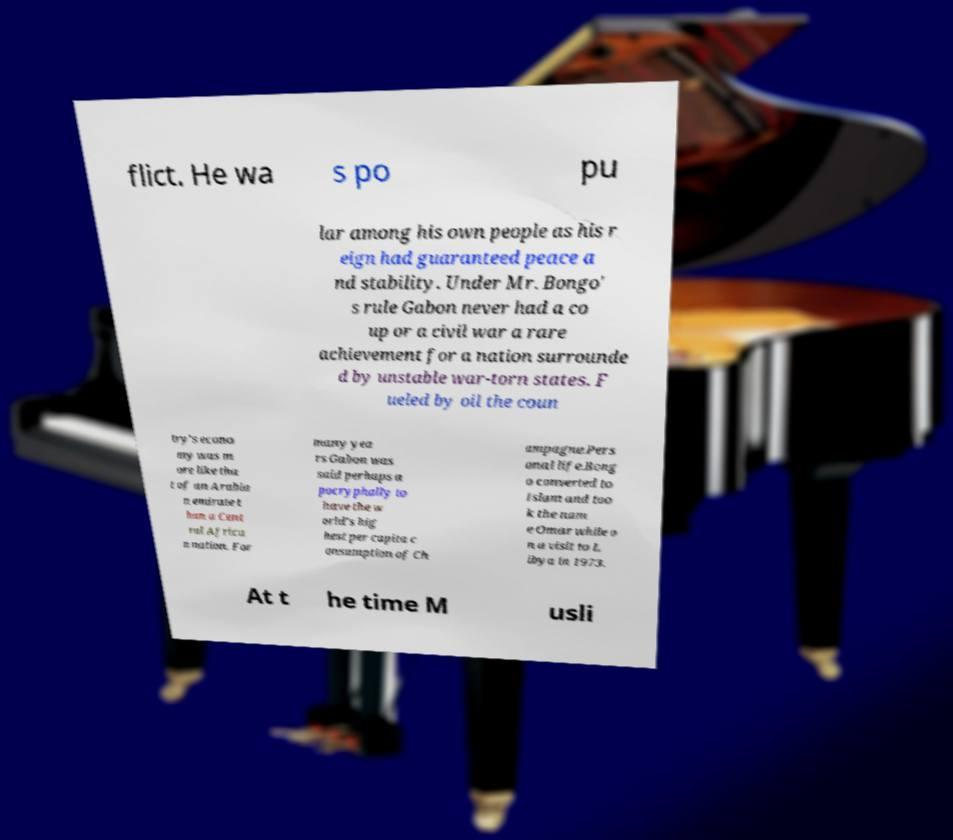Could you assist in decoding the text presented in this image and type it out clearly? flict. He wa s po pu lar among his own people as his r eign had guaranteed peace a nd stability. Under Mr. Bongo' s rule Gabon never had a co up or a civil war a rare achievement for a nation surrounde d by unstable war-torn states. F ueled by oil the coun try's econo my was m ore like tha t of an Arabia n emirate t han a Cent ral Africa n nation. For many yea rs Gabon was said perhaps a pocryphally to have the w orld's hig hest per capita c onsumption of Ch ampagne.Pers onal life.Bong o converted to Islam and too k the nam e Omar while o n a visit to L ibya in 1973. At t he time M usli 